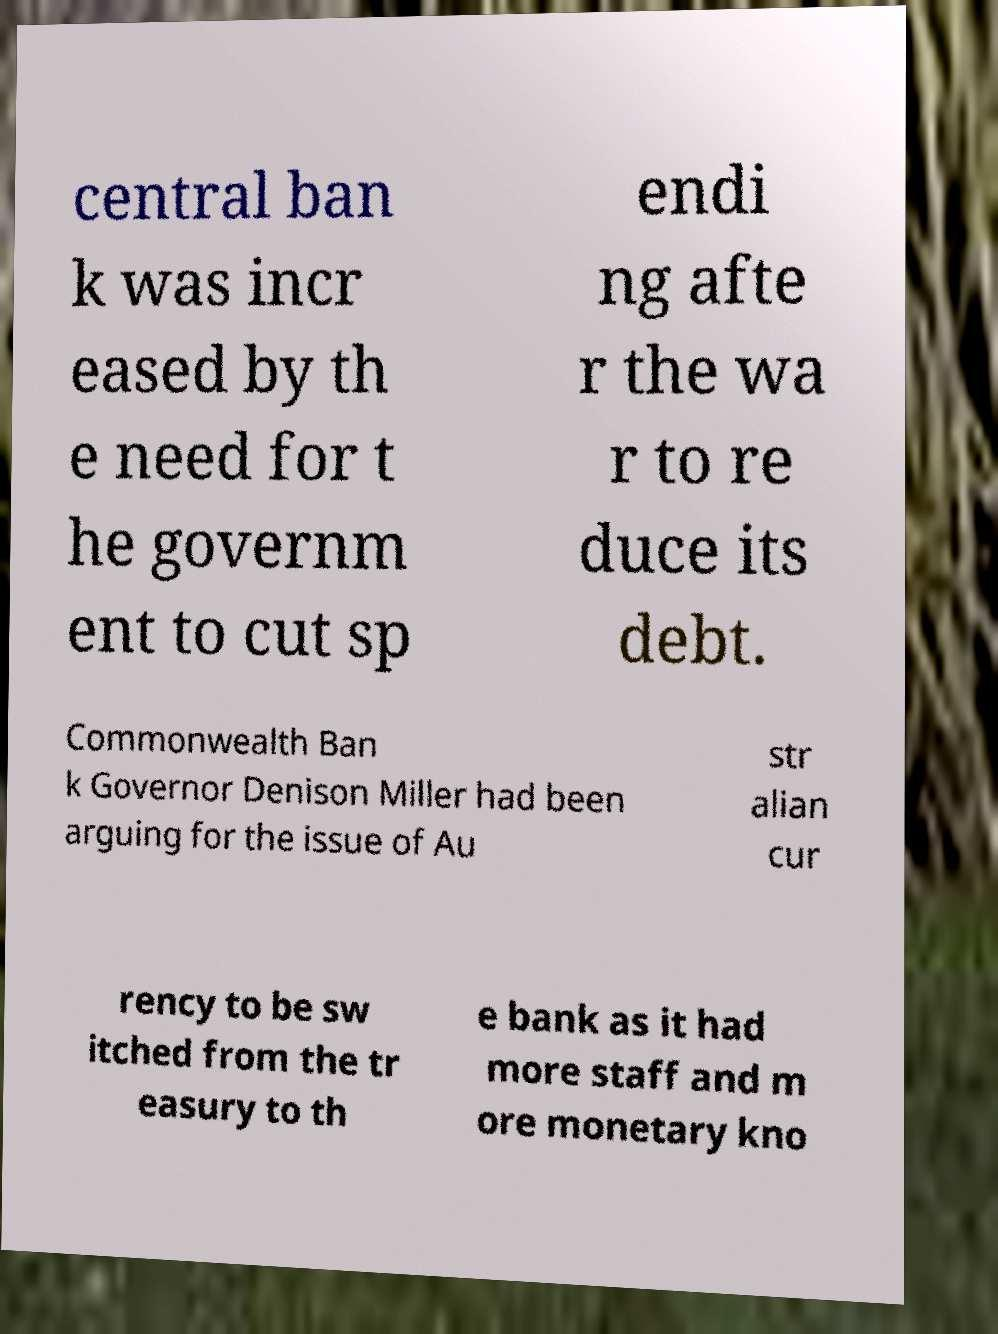Can you accurately transcribe the text from the provided image for me? central ban k was incr eased by th e need for t he governm ent to cut sp endi ng afte r the wa r to re duce its debt. Commonwealth Ban k Governor Denison Miller had been arguing for the issue of Au str alian cur rency to be sw itched from the tr easury to th e bank as it had more staff and m ore monetary kno 